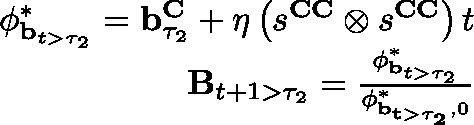<formula> <loc_0><loc_0><loc_500><loc_500>\begin{array} { r } { \phi _ { b _ { t > \tau _ { 2 } } } ^ { * } = b _ { \tau _ { 2 } } ^ { C } + \eta \left ( s ^ { C C } \otimes s ^ { C C } \right ) t } \\ { B _ { t + 1 > \tau _ { 2 } } = \frac { \phi _ { b _ { t > \tau _ { 2 } } } ^ { * } } { \phi _ { { b } _ { t > \tau _ { 2 } } , 0 } ^ { * } } } \end{array}</formula> 